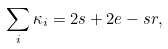Convert formula to latex. <formula><loc_0><loc_0><loc_500><loc_500>\sum _ { i } \kappa _ { i } = 2 s + 2 e - s r ,</formula> 